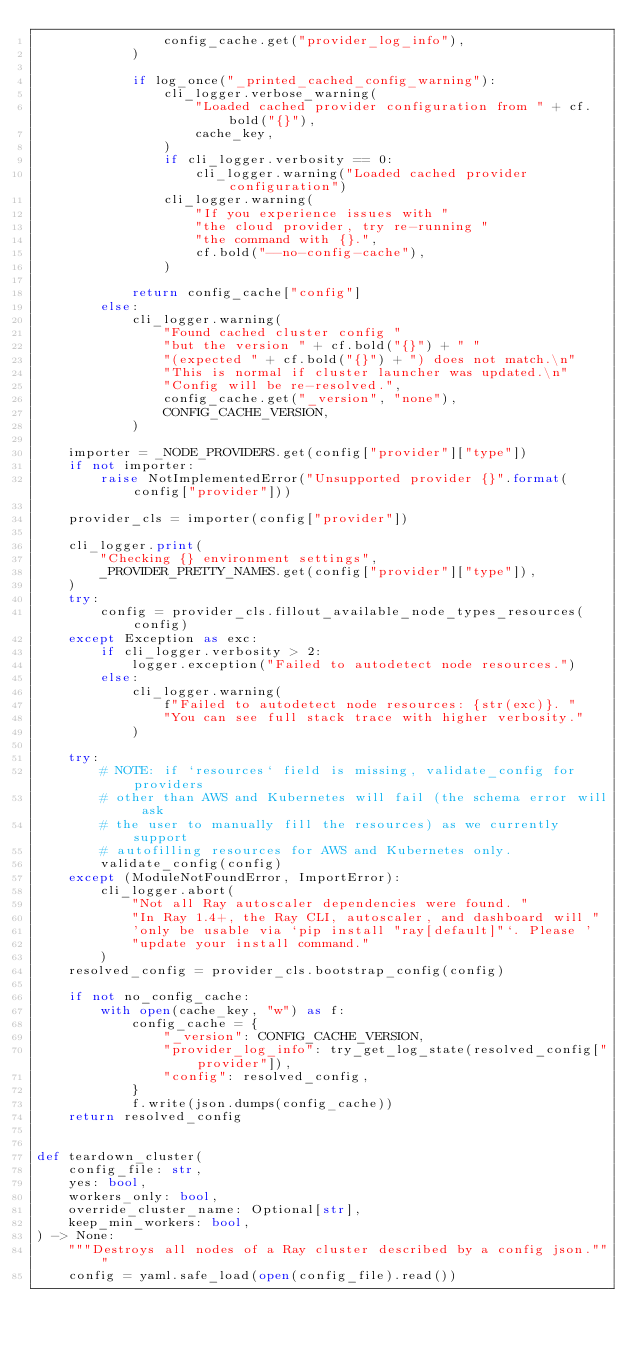<code> <loc_0><loc_0><loc_500><loc_500><_Python_>                config_cache.get("provider_log_info"),
            )

            if log_once("_printed_cached_config_warning"):
                cli_logger.verbose_warning(
                    "Loaded cached provider configuration from " + cf.bold("{}"),
                    cache_key,
                )
                if cli_logger.verbosity == 0:
                    cli_logger.warning("Loaded cached provider configuration")
                cli_logger.warning(
                    "If you experience issues with "
                    "the cloud provider, try re-running "
                    "the command with {}.",
                    cf.bold("--no-config-cache"),
                )

            return config_cache["config"]
        else:
            cli_logger.warning(
                "Found cached cluster config "
                "but the version " + cf.bold("{}") + " "
                "(expected " + cf.bold("{}") + ") does not match.\n"
                "This is normal if cluster launcher was updated.\n"
                "Config will be re-resolved.",
                config_cache.get("_version", "none"),
                CONFIG_CACHE_VERSION,
            )

    importer = _NODE_PROVIDERS.get(config["provider"]["type"])
    if not importer:
        raise NotImplementedError("Unsupported provider {}".format(config["provider"]))

    provider_cls = importer(config["provider"])

    cli_logger.print(
        "Checking {} environment settings",
        _PROVIDER_PRETTY_NAMES.get(config["provider"]["type"]),
    )
    try:
        config = provider_cls.fillout_available_node_types_resources(config)
    except Exception as exc:
        if cli_logger.verbosity > 2:
            logger.exception("Failed to autodetect node resources.")
        else:
            cli_logger.warning(
                f"Failed to autodetect node resources: {str(exc)}. "
                "You can see full stack trace with higher verbosity."
            )

    try:
        # NOTE: if `resources` field is missing, validate_config for providers
        # other than AWS and Kubernetes will fail (the schema error will ask
        # the user to manually fill the resources) as we currently support
        # autofilling resources for AWS and Kubernetes only.
        validate_config(config)
    except (ModuleNotFoundError, ImportError):
        cli_logger.abort(
            "Not all Ray autoscaler dependencies were found. "
            "In Ray 1.4+, the Ray CLI, autoscaler, and dashboard will "
            'only be usable via `pip install "ray[default]"`. Please '
            "update your install command."
        )
    resolved_config = provider_cls.bootstrap_config(config)

    if not no_config_cache:
        with open(cache_key, "w") as f:
            config_cache = {
                "_version": CONFIG_CACHE_VERSION,
                "provider_log_info": try_get_log_state(resolved_config["provider"]),
                "config": resolved_config,
            }
            f.write(json.dumps(config_cache))
    return resolved_config


def teardown_cluster(
    config_file: str,
    yes: bool,
    workers_only: bool,
    override_cluster_name: Optional[str],
    keep_min_workers: bool,
) -> None:
    """Destroys all nodes of a Ray cluster described by a config json."""
    config = yaml.safe_load(open(config_file).read())</code> 